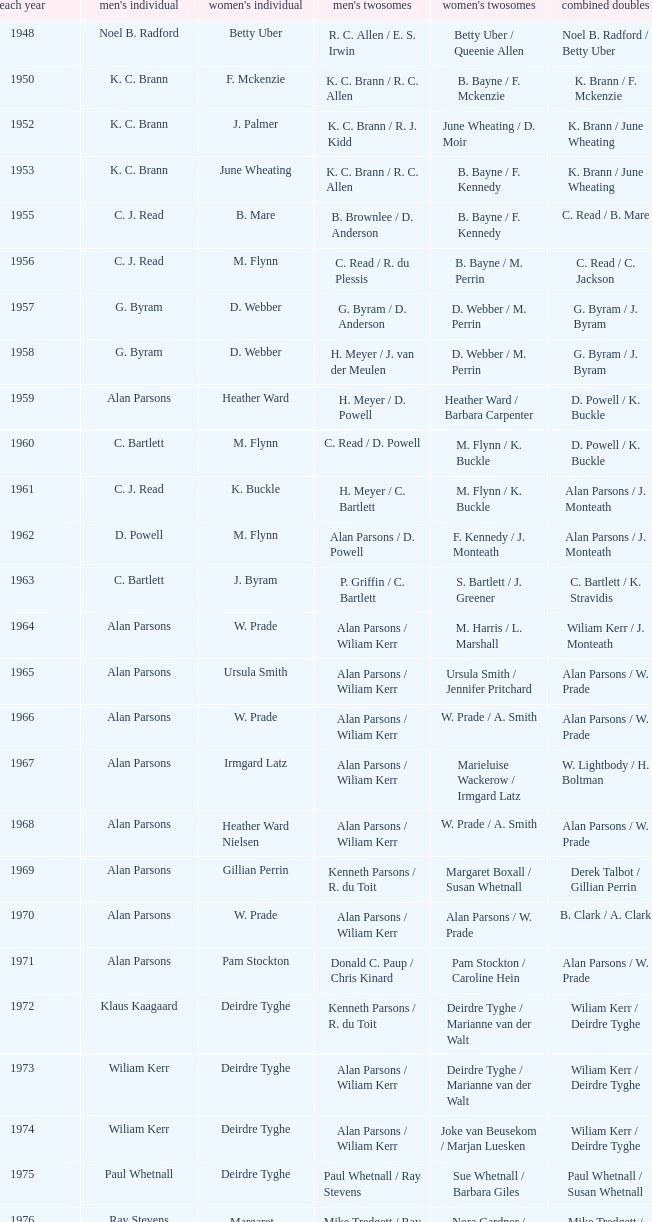Parse the table in full. {'header': ['each year', "men's individual", "women's individual", "men's twosomes", "women's twosomes", 'combined doubles'], 'rows': [['1948', 'Noel B. Radford', 'Betty Uber', 'R. C. Allen / E. S. Irwin', 'Betty Uber / Queenie Allen', 'Noel B. Radford / Betty Uber'], ['1950', 'K. C. Brann', 'F. Mckenzie', 'K. C. Brann / R. C. Allen', 'B. Bayne / F. Mckenzie', 'K. Brann / F. Mckenzie'], ['1952', 'K. C. Brann', 'J. Palmer', 'K. C. Brann / R. J. Kidd', 'June Wheating / D. Moir', 'K. Brann / June Wheating'], ['1953', 'K. C. Brann', 'June Wheating', 'K. C. Brann / R. C. Allen', 'B. Bayne / F. Kennedy', 'K. Brann / June Wheating'], ['1955', 'C. J. Read', 'B. Mare', 'B. Brownlee / D. Anderson', 'B. Bayne / F. Kennedy', 'C. Read / B. Mare'], ['1956', 'C. J. Read', 'M. Flynn', 'C. Read / R. du Plessis', 'B. Bayne / M. Perrin', 'C. Read / C. Jackson'], ['1957', 'G. Byram', 'D. Webber', 'G. Byram / D. Anderson', 'D. Webber / M. Perrin', 'G. Byram / J. Byram'], ['1958', 'G. Byram', 'D. Webber', 'H. Meyer / J. van der Meulen', 'D. Webber / M. Perrin', 'G. Byram / J. Byram'], ['1959', 'Alan Parsons', 'Heather Ward', 'H. Meyer / D. Powell', 'Heather Ward / Barbara Carpenter', 'D. Powell / K. Buckle'], ['1960', 'C. Bartlett', 'M. Flynn', 'C. Read / D. Powell', 'M. Flynn / K. Buckle', 'D. Powell / K. Buckle'], ['1961', 'C. J. Read', 'K. Buckle', 'H. Meyer / C. Bartlett', 'M. Flynn / K. Buckle', 'Alan Parsons / J. Monteath'], ['1962', 'D. Powell', 'M. Flynn', 'Alan Parsons / D. Powell', 'F. Kennedy / J. Monteath', 'Alan Parsons / J. Monteath'], ['1963', 'C. Bartlett', 'J. Byram', 'P. Griffin / C. Bartlett', 'S. Bartlett / J. Greener', 'C. Bartlett / K. Stravidis'], ['1964', 'Alan Parsons', 'W. Prade', 'Alan Parsons / Wiliam Kerr', 'M. Harris / L. Marshall', 'Wiliam Kerr / J. Monteath'], ['1965', 'Alan Parsons', 'Ursula Smith', 'Alan Parsons / Wiliam Kerr', 'Ursula Smith / Jennifer Pritchard', 'Alan Parsons / W. Prade'], ['1966', 'Alan Parsons', 'W. Prade', 'Alan Parsons / Wiliam Kerr', 'W. Prade / A. Smith', 'Alan Parsons / W. Prade'], ['1967', 'Alan Parsons', 'Irmgard Latz', 'Alan Parsons / Wiliam Kerr', 'Marieluise Wackerow / Irmgard Latz', 'W. Lightbody / H. Boltman'], ['1968', 'Alan Parsons', 'Heather Ward Nielsen', 'Alan Parsons / Wiliam Kerr', 'W. Prade / A. Smith', 'Alan Parsons / W. Prade'], ['1969', 'Alan Parsons', 'Gillian Perrin', 'Kenneth Parsons / R. du Toit', 'Margaret Boxall / Susan Whetnall', 'Derek Talbot / Gillian Perrin'], ['1970', 'Alan Parsons', 'W. Prade', 'Alan Parsons / Wiliam Kerr', 'Alan Parsons / W. Prade', 'B. Clark / A. Clark'], ['1971', 'Alan Parsons', 'Pam Stockton', 'Donald C. Paup / Chris Kinard', 'Pam Stockton / Caroline Hein', 'Alan Parsons / W. Prade'], ['1972', 'Klaus Kaagaard', 'Deirdre Tyghe', 'Kenneth Parsons / R. du Toit', 'Deirdre Tyghe / Marianne van der Walt', 'Wiliam Kerr / Deirdre Tyghe'], ['1973', 'Wiliam Kerr', 'Deirdre Tyghe', 'Alan Parsons / Wiliam Kerr', 'Deirdre Tyghe / Marianne van der Walt', 'Wiliam Kerr / Deirdre Tyghe'], ['1974', 'Wiliam Kerr', 'Deirdre Tyghe', 'Alan Parsons / Wiliam Kerr', 'Joke van Beusekom / Marjan Luesken', 'Wiliam Kerr / Deirdre Tyghe'], ['1975', 'Paul Whetnall', 'Deirdre Tyghe', 'Paul Whetnall / Ray Stevens', 'Sue Whetnall / Barbara Giles', 'Paul Whetnall / Susan Whetnall'], ['1976', 'Ray Stevens', 'Margaret Lockwood', 'Mike Tredgett / Ray Stevens', 'Nora Gardner / Margaret Lockwood', 'Mike Tredgett / Nora Gardner'], ['1977', 'Wiliam Kerr', 'Deirdre Algie', 'Kenneth Parsons / Wiliam Kerr', 'Gussie Botes / Marianne van der Walt', 'Kenneth Parsons / Deirdre Algie'], ['1978', 'Gordon McMillan', 'Deirdre Algie', 'Gordon McMillan / John Abrahams', 'Gussie Botes / Marianne Abrahams', 'Kenneth Parsons / Deirdre Algie'], ['1979', 'Johan Croukamp', 'Gussie Botes', 'Gordon McMillan / John Abrahams', 'Gussie Botes / Marianne Abrahams', 'Alan Phillips / Gussie Botes'], ['1980', 'Chris Kinard', 'Utami Kinard', 'Alan Phillips / Kenneth Parsons', 'Gussie Phillips / Marianne Abrahams', 'Alan Phillips / Gussie Phillips'], ['1981', 'Johan Bosman', 'Deirdre Algie', 'Alan Phillips / Kenneth Parsons', 'Deirdre Algie / Karen Glenister', 'Alan Phillips / Gussie Phillips'], ['1982', 'Alan Phillips', 'Gussie Phillips', 'Alan Phillips / Kenneth Parsons', 'Gussie Phillips / Tracey Phillips', 'Alan Phillips / Gussie Phillips'], ['1983', 'Johan Croukamp', 'Gussie Phillips', 'Alan Phillips / David Phillips', 'Gussie Phillips / Tracey Phillips', 'Alan Phillips / Gussie Phillips'], ['1984', 'Johan Croukamp', 'Karen Glenister', 'Alan Phillips / David Phillips', 'Gussie Phillips / Tracey Phillips', 'Alan Phillips / Gussie Phillips'], ['1985', 'Johan Bosman', 'Gussie Phillips', 'Alan Phillips / David Phillips', 'Deirdre Algie / L. Humphrey', 'Alan Phillips / Gussie Phillips'], ['1986', 'Johan Bosman', 'Vanessa van der Walt', 'Alan Phillips / David Phillips', 'Gussie Phillips / Tracey Thompson', 'Alan Phillips / Gussie Phillips'], ['1987', 'Johan Bosman', 'Gussie Phillips', 'Alan Phillips / David Phillips', 'Gussie Phillips / Tracey Thompson', 'Alan Phillips / Gussie Phillips'], ['1988', 'Alan Phillips', 'Gussie Phillips', 'Alan Phillips / David Phillips', 'Gussie Phillips / Tracey Thompson', 'Alan Phillips / Gussie Phillips'], ['1989', 'Alan Phillips', 'Lina Fourie', 'Kenneth Parsons / Nico Meerholz', 'Gussie Phillips / Tracey Thompson', 'Alan Phillips / Gussie Phillips'], ['1990', 'Alan Phillips', 'Lina Fourie', 'Anton Kriel / Nico Meerholz', 'Gussie Phillips / Tracey Thompson', 'Alan Phillips / Gussie Phillips'], ['1991', 'Anton Kriel', 'Lina Fourie', 'Anton Kriel / Nico Meerholz', 'Lina Fourie / E. Fourie', 'Anton Kriel / Vanessa van der Walt'], ['1992', 'D. Plasson', 'Lina Fourie', 'Anton Kriel / Nico Meerholz', 'Gussie Phillips / Tracey Thompson', 'Anton Kriel / Vanessa van der Walt'], ['1993', 'Johan Kleingeld', 'Lina Fourie', 'Anton Kriel / Nico Meerholz', 'Gussie Phillips / Tracey Thompson', 'Johan Kleingeld / Lina Fourie'], ['1994', 'Johan Kleingeld', 'Lina Fourie', 'Anton Kriel / Nico Meerholz', 'Lina Fourie / Beverley Meerholz', 'Johan Kleingeld / Lina Fourie'], ['1995', 'Johan Kleingeld', 'Lina Fourie', 'Johan Kleingeld / Gavin Polmans', 'L. Humphrey / Monique Till', 'Alan Phillips / Gussie Phillips'], ['1996', 'Warren Parsons', 'Lina Fourie', 'Johan Kleingeld / Gavin Polmans', 'Linda Montignies / Monique Till', 'Anton Kriel / Vanessa van der Walt'], ['1997', 'Johan Kleingeld', 'Lina Fourie', 'Warren Parsons / Neale Woodroffe', 'Lina Fourie / Tracey Thompson', 'Johan Kleingeld / Lina Fourie'], ['1998', 'Johan Kleingeld', 'Lina Fourie', 'Gavin Polmans / Neale Woodroffe', 'Linda Montignies / Monique Ric-Hansen', 'Anton Kriel / Michelle Edwards'], ['1999', 'Michael Adams', 'Lina Fourie', 'Johan Kleingeld / Anton Kriel', 'Linda Montignies / Monique Ric-Hansen', 'Johan Kleingeld / Karen Coetzer'], ['2000', 'Michael Adams', 'Michelle Edwards', 'Nico Meerholz / Anton Kriel', 'Lina Fourie / Karen Coetzer', 'Anton Kriel / Michelle Edwards'], ['2001', 'Stewart Carson', 'Michelle Edwards', 'Chris Dednam / Johan Kleingeld', 'Lina Fourie / Karen Coetzer', 'Chris Dednam / Antoinette Uys'], ['2002', 'Stewart Carson', 'Michelle Edwards', 'Chris Dednam / Johan Kleingeld', 'Michelle Edwards / Chantal Botts', 'Johan Kleingeld / Marika Daubern'], ['2003', 'Chris Dednam', 'Michelle Edwards', 'Chris Dednam / Johan Kleingeld', 'Michelle Edwards / Chantal Botts', 'Johan Kleingeld / Marika Daubern'], ['2004', 'Chris Dednam', 'Michelle Edwards', 'Chris Dednam / Roelof Dednam', 'Michelle Edwards / Chantal Botts', 'Dorian James / Michelle Edwards'], ['2005', 'Chris Dednam', 'Marika Daubern', 'Chris Dednam / Roelof Dednam', 'Marika Daubern / Kerry Lee Harrington', 'Johan Kleingeld / Marika Daubern'], ['2006', 'Chris Dednam', 'Kerry Lee Harrington', 'Chris Dednam / Roelof Dednam', 'Michelle Edwards / Chantal Botts', 'Dorian James / Michelle Edwards'], ['2007', 'Wiaan Viljoen', 'Stacey Doubell', 'Chris Dednam / Roelof Dednam', 'Michelle Edwards / Chantal Botts', 'Dorian James / Michelle Edwards'], ['2008', 'Chris Dednam', 'Stacey Doubell', 'Chris Dednam / Roelof Dednam', 'Michelle Edwards / Chantal Botts', 'Chris Dednam / Michelle Edwards'], ['2009', 'Roelof Dednam', 'Kerry Lee Harrington', 'Dorian James / Wiaan Viljoen', 'Michelle Edwards / Annari Viljoen', 'Chris Dednam / Annari Viljoen']]} Which Men's doubles have a Year smaller than 1960, and Men's singles of noel b. radford? R. C. Allen / E. S. Irwin. 